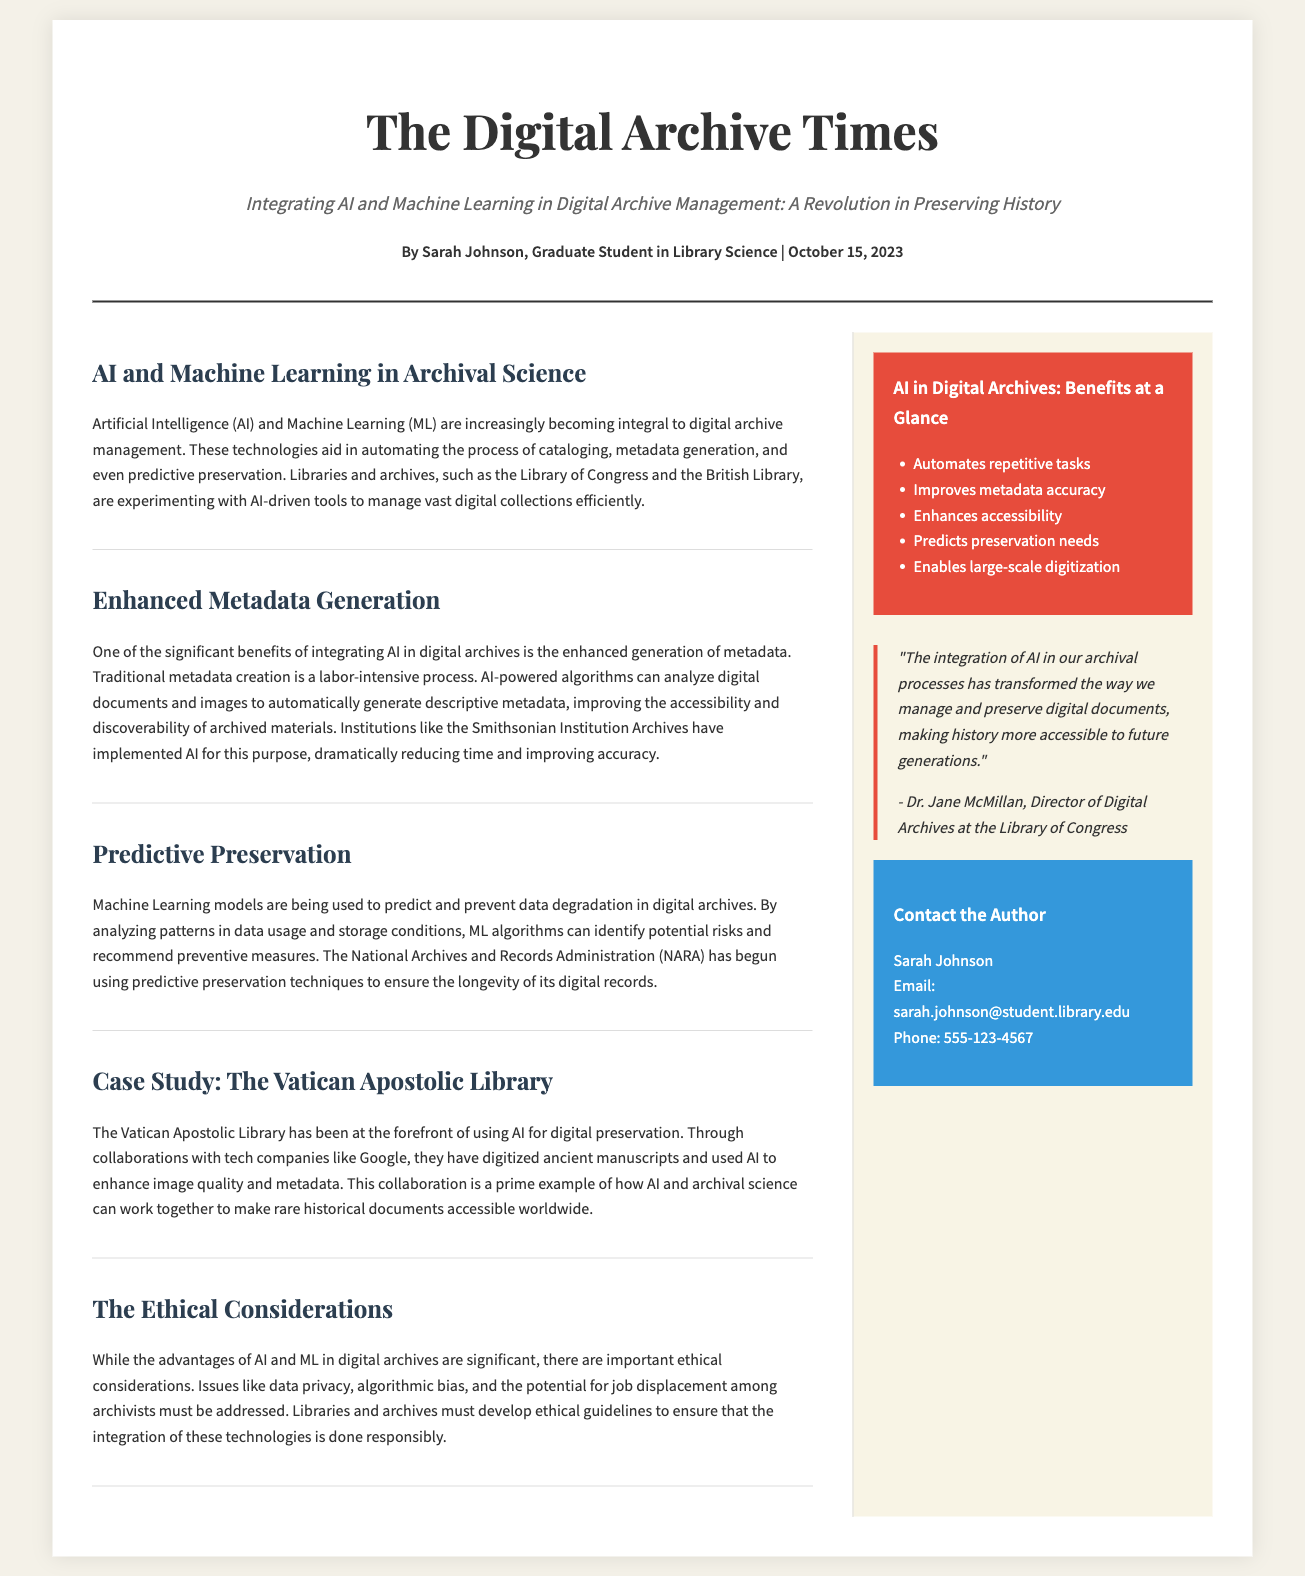What is the title of the article? The title of the article is prominently displayed in the header section of the document.
Answer: Integrating AI and Machine Learning in Digital Archive Management: A Revolution in Preserving History Who is the author of the article? The author is mentioned in the byline section of the document.
Answer: Sarah Johnson When was the article published? The publication date is also included in the byline section of the document.
Answer: October 15, 2023 What institution is mentioned for its use of AI in metadata generation? This information is found in the section discussing enhanced metadata generation.
Answer: Smithsonian Institution Archives What is one benefit of AI in digital archives listed in the infographic? The infographic summarizes the advantages of AI in digital archives.
Answer: Automates repetitive tasks What ethical consideration is discussed in the document? The document addresses several ethical considerations in the section titled "The Ethical Considerations."
Answer: Data privacy What is the name of the library collaborating with Google for AI use? This specific collaboration is mentioned in the case study portion of the document.
Answer: Vatican Apostolic Library Which organization is beginning to use predictive preservation techniques? The document mentions this organization in the section on predictive preservation.
Answer: National Archives and Records Administration 